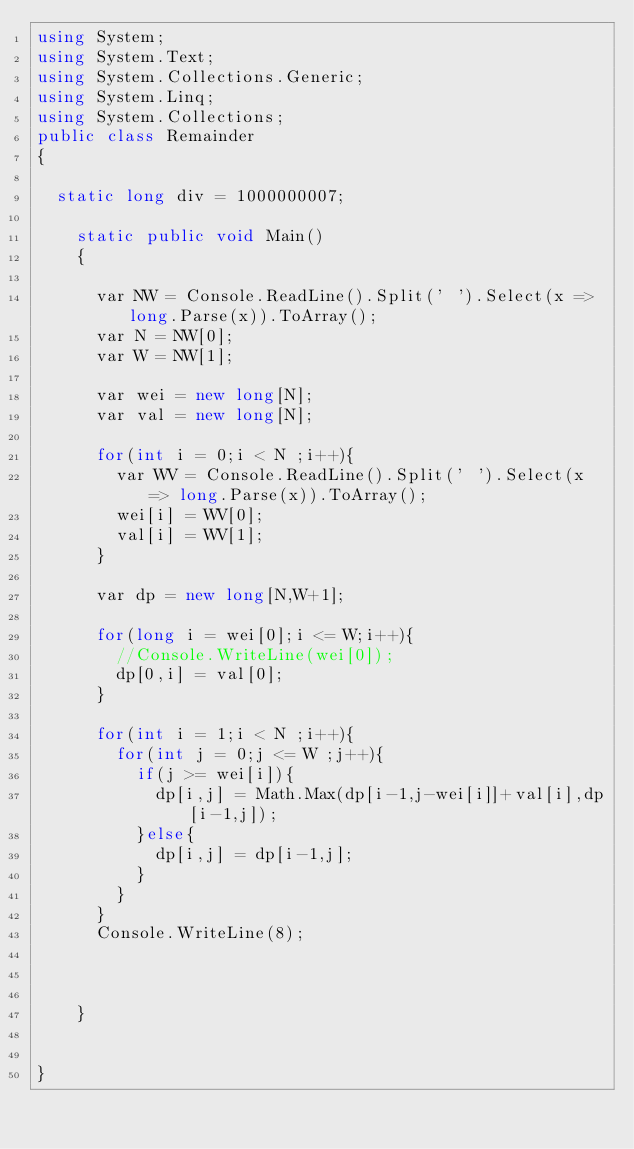<code> <loc_0><loc_0><loc_500><loc_500><_C#_>using System;
using System.Text;
using System.Collections.Generic;
using System.Linq;
using System.Collections;
public class Remainder
{

  static long div = 1000000007;

    static public void Main()
    {
      
      var NW = Console.ReadLine().Split(' ').Select(x => long.Parse(x)).ToArray();
      var N = NW[0];
      var W = NW[1];
      
      var wei = new long[N];
      var val = new long[N];
      
      for(int i = 0;i < N ;i++){
        var WV = Console.ReadLine().Split(' ').Select(x => long.Parse(x)).ToArray();
        wei[i] = WV[0];
        val[i] = WV[1];
      }
      
      var dp = new long[N,W+1];
      
      for(long i = wei[0];i <= W;i++){
        //Console.WriteLine(wei[0]);
        dp[0,i] = val[0];
      }
      
      for(int i = 1;i < N ;i++){
        for(int j = 0;j <= W ;j++){
          if(j >= wei[i]){
            dp[i,j] = Math.Max(dp[i-1,j-wei[i]]+val[i],dp[i-1,j]);
          }else{
            dp[i,j] = dp[i-1,j];
          }
        }
      }
      Console.WriteLine(8);
      
      
      
    }
 

}
</code> 